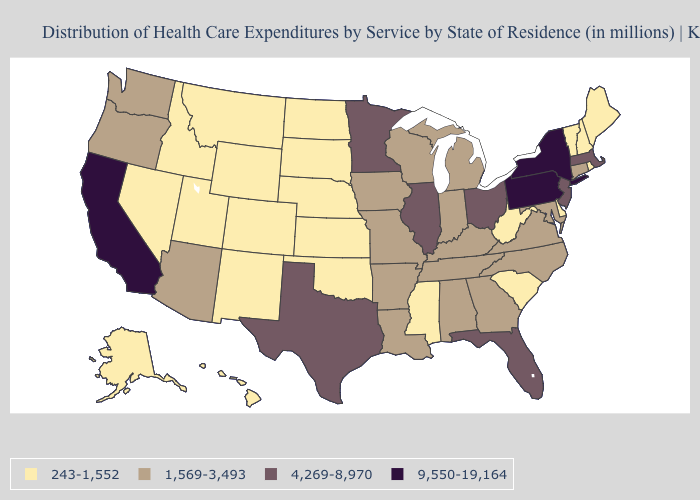Does Arkansas have a higher value than Montana?
Quick response, please. Yes. What is the value of Tennessee?
Keep it brief. 1,569-3,493. What is the lowest value in the USA?
Short answer required. 243-1,552. What is the value of Illinois?
Answer briefly. 4,269-8,970. How many symbols are there in the legend?
Give a very brief answer. 4. Name the states that have a value in the range 4,269-8,970?
Be succinct. Florida, Illinois, Massachusetts, Minnesota, New Jersey, Ohio, Texas. Name the states that have a value in the range 4,269-8,970?
Short answer required. Florida, Illinois, Massachusetts, Minnesota, New Jersey, Ohio, Texas. Among the states that border Delaware , does Pennsylvania have the highest value?
Short answer required. Yes. Among the states that border Arizona , which have the lowest value?
Concise answer only. Colorado, Nevada, New Mexico, Utah. Name the states that have a value in the range 243-1,552?
Keep it brief. Alaska, Colorado, Delaware, Hawaii, Idaho, Kansas, Maine, Mississippi, Montana, Nebraska, Nevada, New Hampshire, New Mexico, North Dakota, Oklahoma, Rhode Island, South Carolina, South Dakota, Utah, Vermont, West Virginia, Wyoming. What is the lowest value in the West?
Answer briefly. 243-1,552. Does the map have missing data?
Concise answer only. No. How many symbols are there in the legend?
Keep it brief. 4. Among the states that border Ohio , does Indiana have the highest value?
Write a very short answer. No. What is the value of Florida?
Quick response, please. 4,269-8,970. 